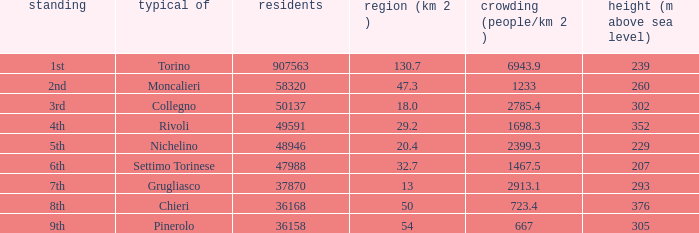What is the crowdedness level in the common of chieri? 723.4. 